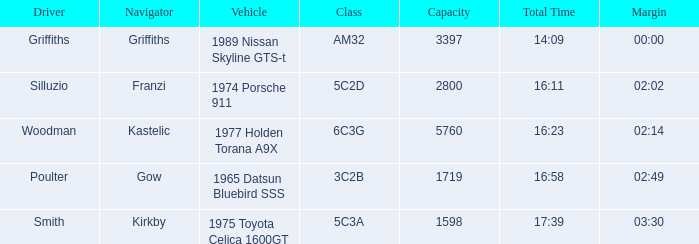What is the lowest capacity for the 1975 toyota celica 1600gt? 1598.0. 